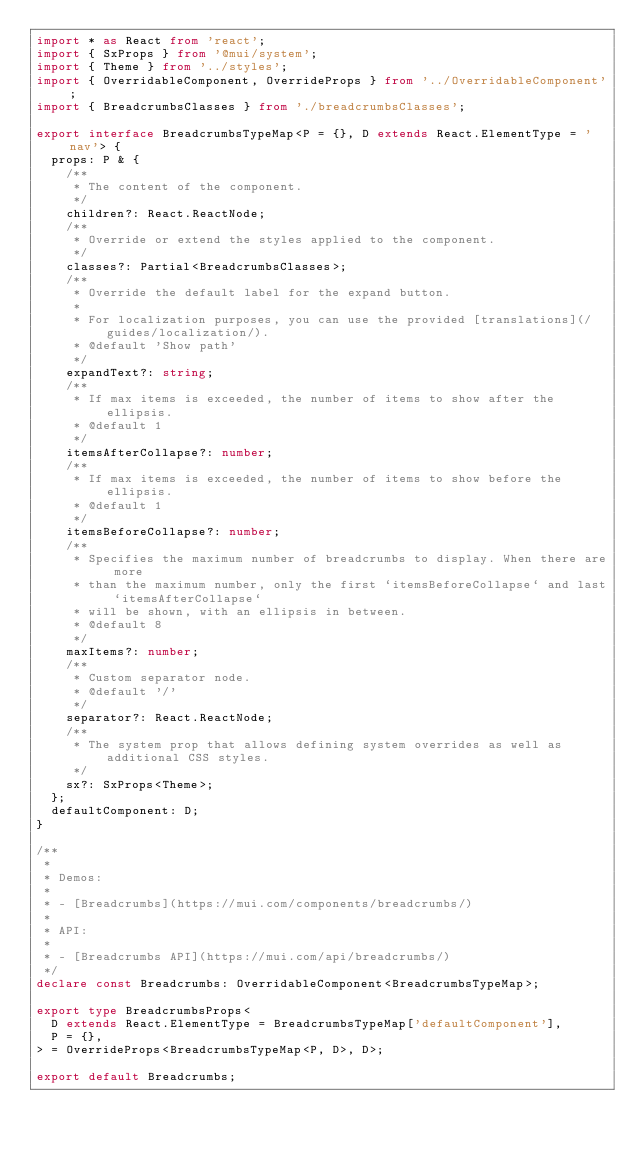Convert code to text. <code><loc_0><loc_0><loc_500><loc_500><_TypeScript_>import * as React from 'react';
import { SxProps } from '@mui/system';
import { Theme } from '../styles';
import { OverridableComponent, OverrideProps } from '../OverridableComponent';
import { BreadcrumbsClasses } from './breadcrumbsClasses';

export interface BreadcrumbsTypeMap<P = {}, D extends React.ElementType = 'nav'> {
  props: P & {
    /**
     * The content of the component.
     */
    children?: React.ReactNode;
    /**
     * Override or extend the styles applied to the component.
     */
    classes?: Partial<BreadcrumbsClasses>;
    /**
     * Override the default label for the expand button.
     *
     * For localization purposes, you can use the provided [translations](/guides/localization/).
     * @default 'Show path'
     */
    expandText?: string;
    /**
     * If max items is exceeded, the number of items to show after the ellipsis.
     * @default 1
     */
    itemsAfterCollapse?: number;
    /**
     * If max items is exceeded, the number of items to show before the ellipsis.
     * @default 1
     */
    itemsBeforeCollapse?: number;
    /**
     * Specifies the maximum number of breadcrumbs to display. When there are more
     * than the maximum number, only the first `itemsBeforeCollapse` and last `itemsAfterCollapse`
     * will be shown, with an ellipsis in between.
     * @default 8
     */
    maxItems?: number;
    /**
     * Custom separator node.
     * @default '/'
     */
    separator?: React.ReactNode;
    /**
     * The system prop that allows defining system overrides as well as additional CSS styles.
     */
    sx?: SxProps<Theme>;
  };
  defaultComponent: D;
}

/**
 *
 * Demos:
 *
 * - [Breadcrumbs](https://mui.com/components/breadcrumbs/)
 *
 * API:
 *
 * - [Breadcrumbs API](https://mui.com/api/breadcrumbs/)
 */
declare const Breadcrumbs: OverridableComponent<BreadcrumbsTypeMap>;

export type BreadcrumbsProps<
  D extends React.ElementType = BreadcrumbsTypeMap['defaultComponent'],
  P = {},
> = OverrideProps<BreadcrumbsTypeMap<P, D>, D>;

export default Breadcrumbs;
</code> 